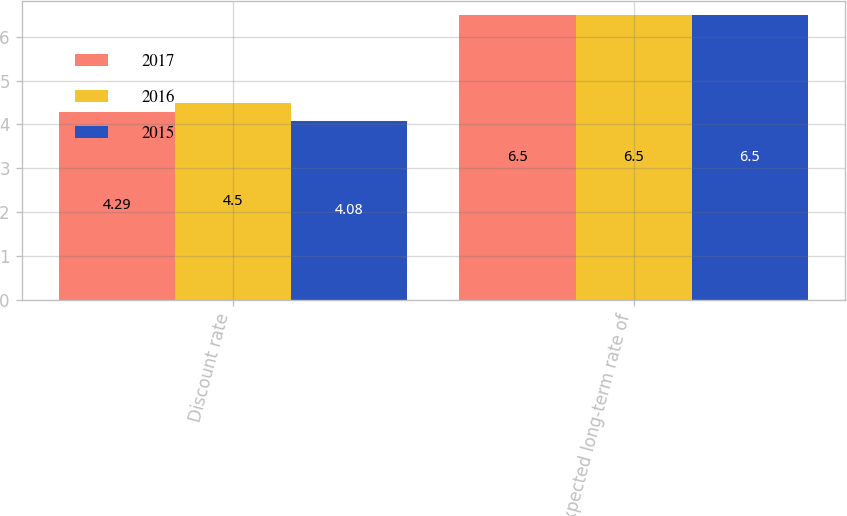Convert chart. <chart><loc_0><loc_0><loc_500><loc_500><stacked_bar_chart><ecel><fcel>Discount rate<fcel>Expected long-term rate of<nl><fcel>2017<fcel>4.29<fcel>6.5<nl><fcel>2016<fcel>4.5<fcel>6.5<nl><fcel>2015<fcel>4.08<fcel>6.5<nl></chart> 